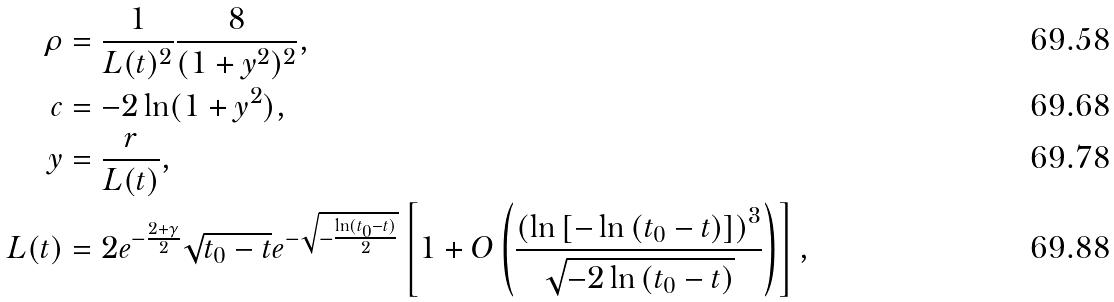<formula> <loc_0><loc_0><loc_500><loc_500>\rho & = \frac { 1 } { L ( t ) ^ { 2 } } \frac { 8 } { ( 1 + y ^ { 2 } ) ^ { 2 } } , \\ c & = - 2 \ln ( 1 + y ^ { 2 } ) , \\ y & = \frac { r } { L ( t ) } , \\ L ( t ) & = 2 e ^ { - \frac { 2 + \gamma } { 2 } } \sqrt { t _ { 0 } - t } e ^ { - \sqrt { - \frac { \ln ( t _ { 0 } - t ) } { 2 } } } \left [ 1 + O \left ( \frac { \left ( \ln { [ - \ln { ( t _ { 0 } - t ) } ] } \right ) ^ { 3 } } { \sqrt { - 2 \ln { ( t _ { 0 } - t ) } } } \right ) \right ] ,</formula> 